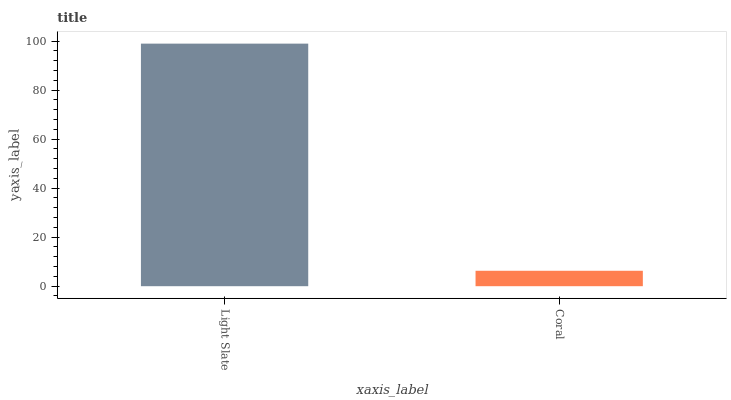Is Coral the maximum?
Answer yes or no. No. Is Light Slate greater than Coral?
Answer yes or no. Yes. Is Coral less than Light Slate?
Answer yes or no. Yes. Is Coral greater than Light Slate?
Answer yes or no. No. Is Light Slate less than Coral?
Answer yes or no. No. Is Light Slate the high median?
Answer yes or no. Yes. Is Coral the low median?
Answer yes or no. Yes. Is Coral the high median?
Answer yes or no. No. Is Light Slate the low median?
Answer yes or no. No. 